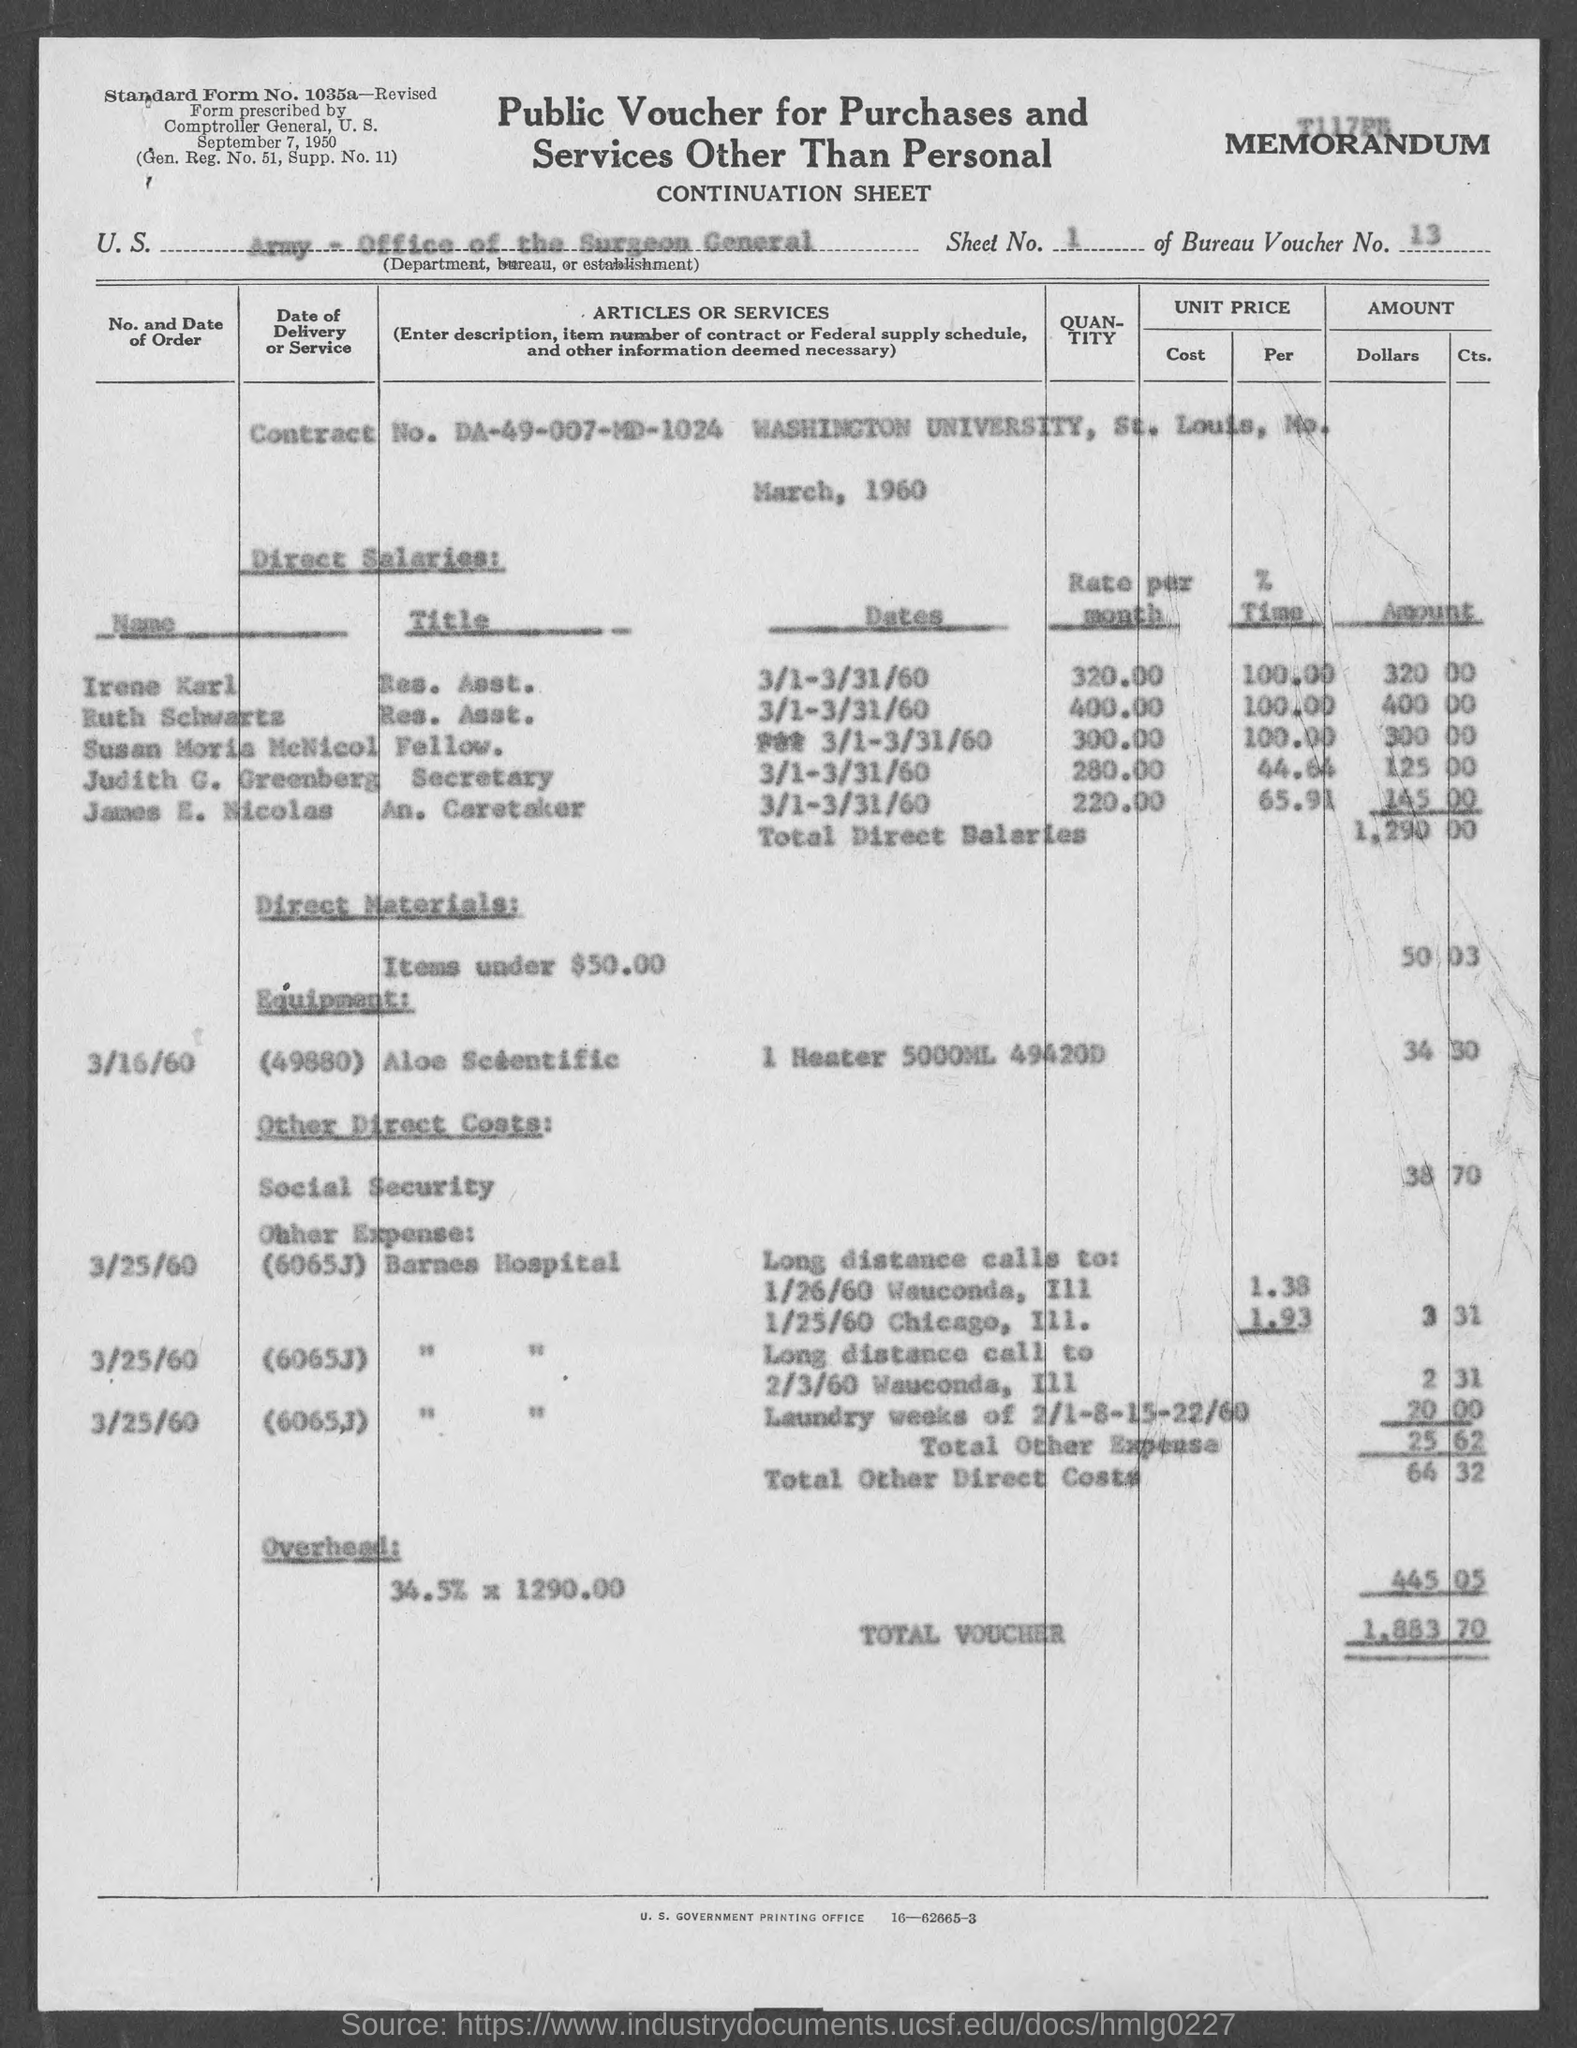Mention a couple of crucial points in this snapshot. The amount for direct materials mentioned in the given form is 50. The Bureau Voucher Number mentioned in the provided form is 13... The total voucher amount mentioned in the given form is 1,883, and it was last updated on January 24, 2023. The sheet number mentioned in the given form is 1.. The amount for total other direct costs mentioned in the given voucher is 64 and 32. 